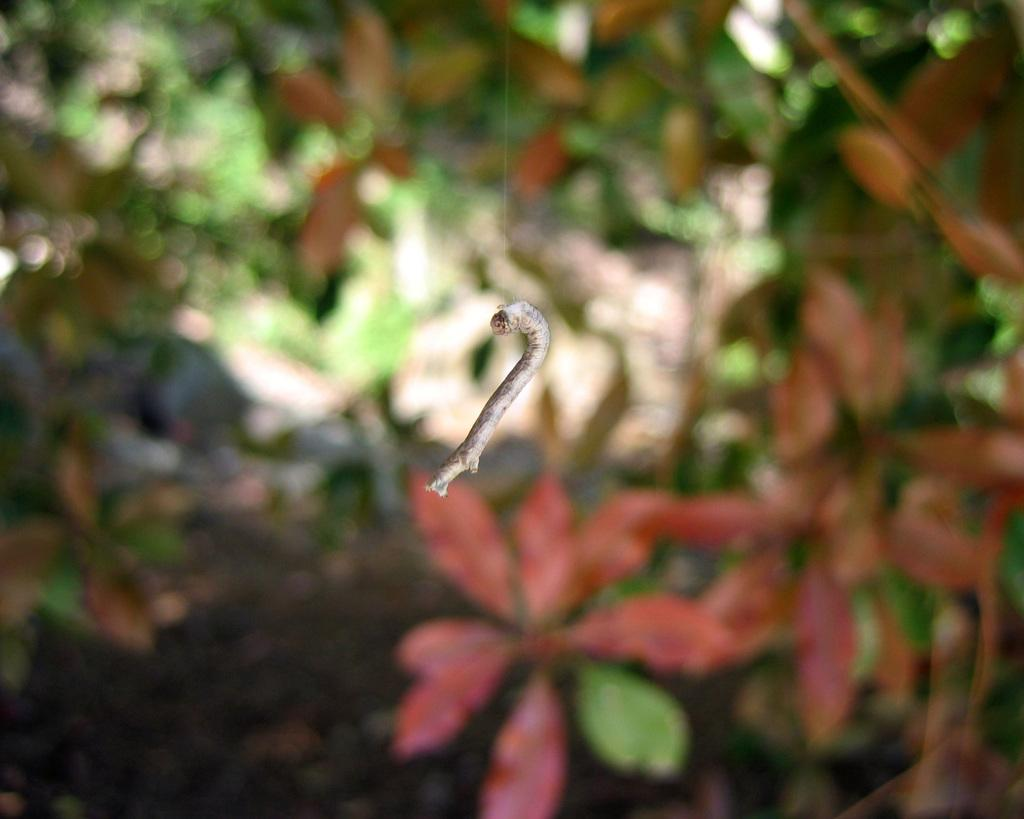What object can be seen in the image that resembles a small stick? There is a small stick in the image. What type of living organisms are visible in the image? Plants are visible in the image, located at the backside. What type of work is being done by the zephyr in the image? There is no zephyr present in the image, and therefore no work being done by it. Is there any indication of a jail in the image? There is no indication of a jail in the image. 